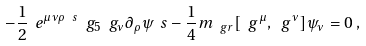<formula> <loc_0><loc_0><loc_500><loc_500>- \frac { 1 } { 2 } \ e ^ { \mu \nu \rho \ s } \ g _ { 5 } \ g _ { \nu } \partial _ { \rho } \psi _ { \ } s - \frac { 1 } { 4 } m _ { \ g r } [ \ g ^ { \mu } , \ g ^ { \nu } ] \psi _ { \nu } = 0 \, ,</formula> 